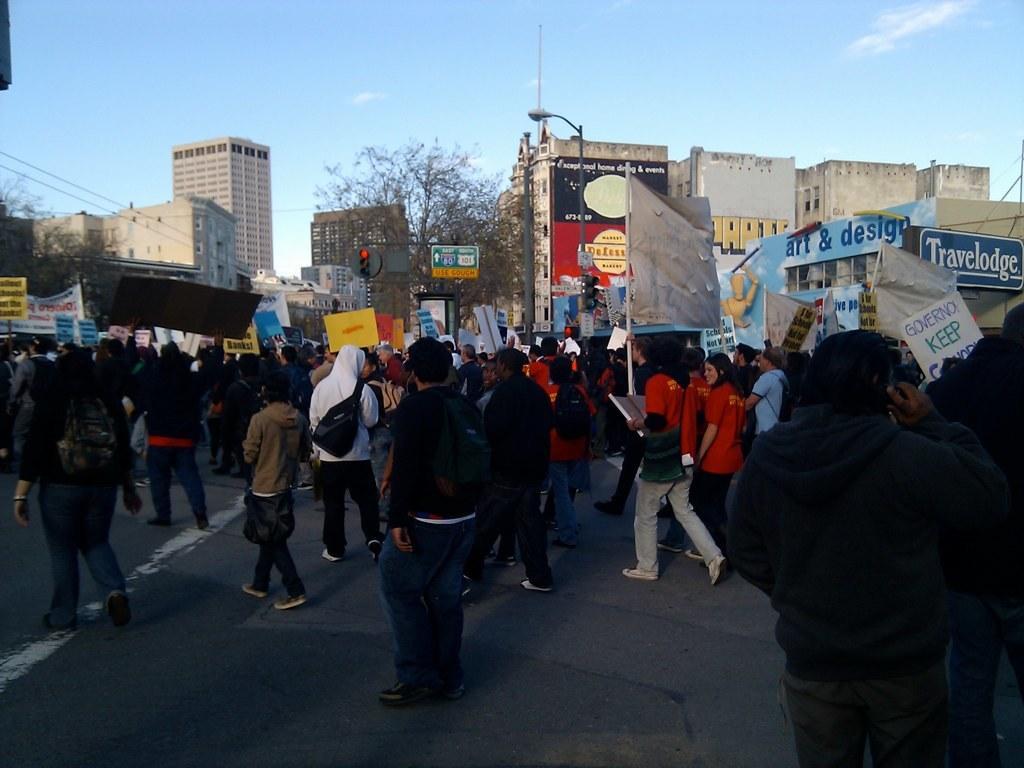How would you summarize this image in a sentence or two? In this image we can see few people on the road, some of them are holding board, some of them are holding banners, there are traffic lights, a street light, few buildings, boards to the building and the sky in the background. 